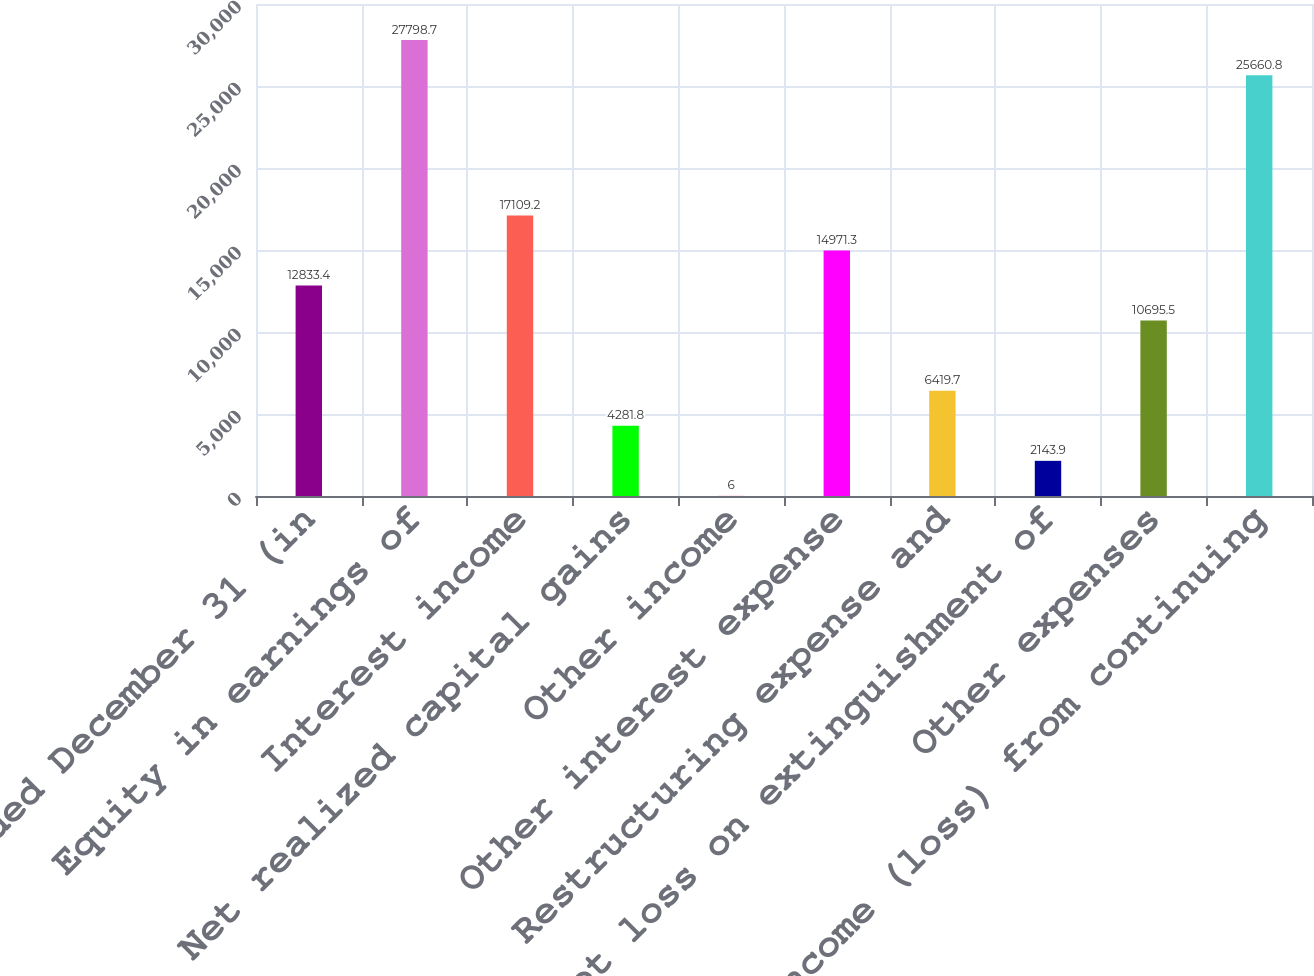<chart> <loc_0><loc_0><loc_500><loc_500><bar_chart><fcel>Years Ended December 31 (in<fcel>Equity in earnings of<fcel>Interest income<fcel>Net realized capital gains<fcel>Other income<fcel>Other interest expense<fcel>Restructuring expense and<fcel>Net loss on extinguishment of<fcel>Other expenses<fcel>Income (loss) from continuing<nl><fcel>12833.4<fcel>27798.7<fcel>17109.2<fcel>4281.8<fcel>6<fcel>14971.3<fcel>6419.7<fcel>2143.9<fcel>10695.5<fcel>25660.8<nl></chart> 